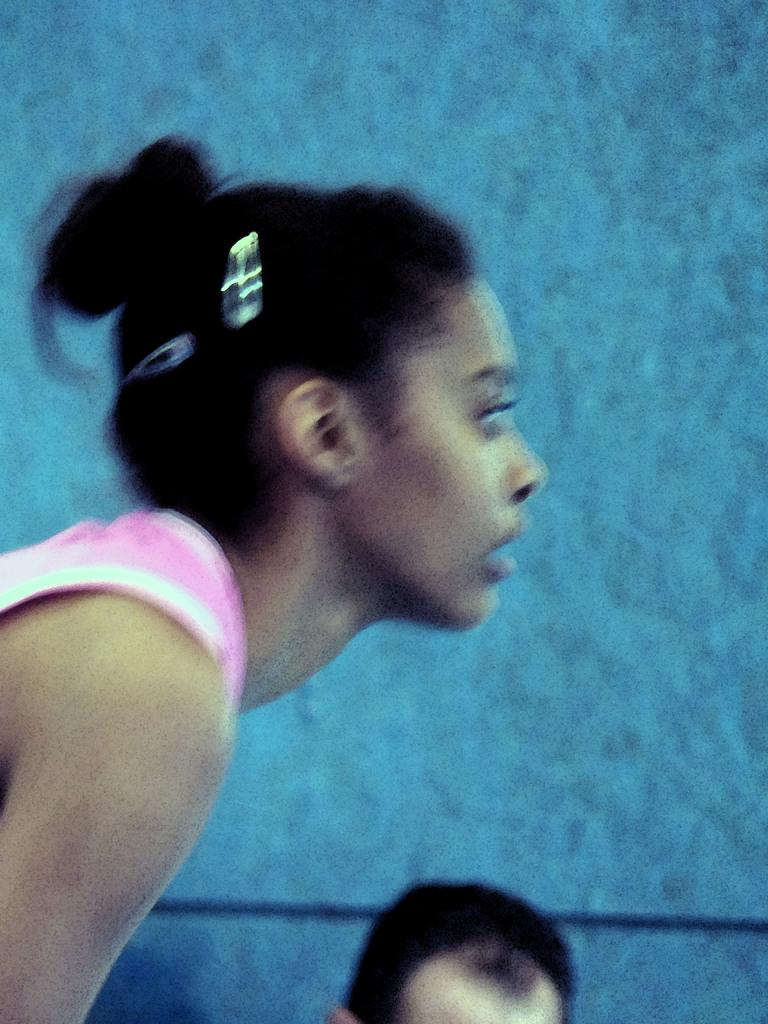Who is the main subject in the image? There is a woman in the image. Can you describe any unique features about the woman? There is a person's head visible on the backside of the woman. What else can be seen in the image besides the woman? There is a wall visible in the image. What type of mailbox is located on the top of the wall in the image? There is no mailbox present in the image; only a woman and a wall are visible. Can you tell me the relationship between the woman and the person whose head is visible on her backside? The provided facts do not give any information about the relationship between the woman and the person whose head is visible on her backside. 